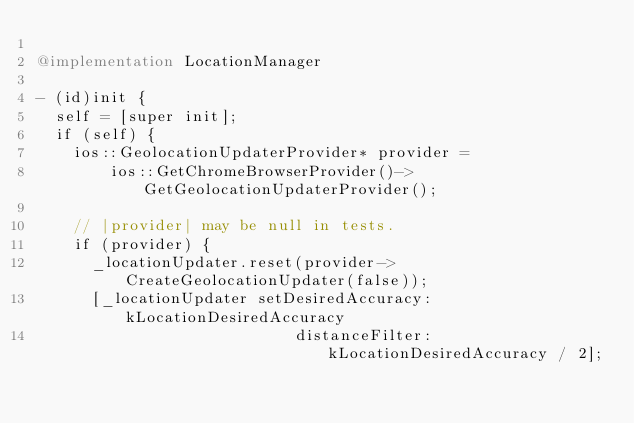Convert code to text. <code><loc_0><loc_0><loc_500><loc_500><_ObjectiveC_>
@implementation LocationManager

- (id)init {
  self = [super init];
  if (self) {
    ios::GeolocationUpdaterProvider* provider =
        ios::GetChromeBrowserProvider()->GetGeolocationUpdaterProvider();

    // |provider| may be null in tests.
    if (provider) {
      _locationUpdater.reset(provider->CreateGeolocationUpdater(false));
      [_locationUpdater setDesiredAccuracy:kLocationDesiredAccuracy
                            distanceFilter:kLocationDesiredAccuracy / 2];</code> 